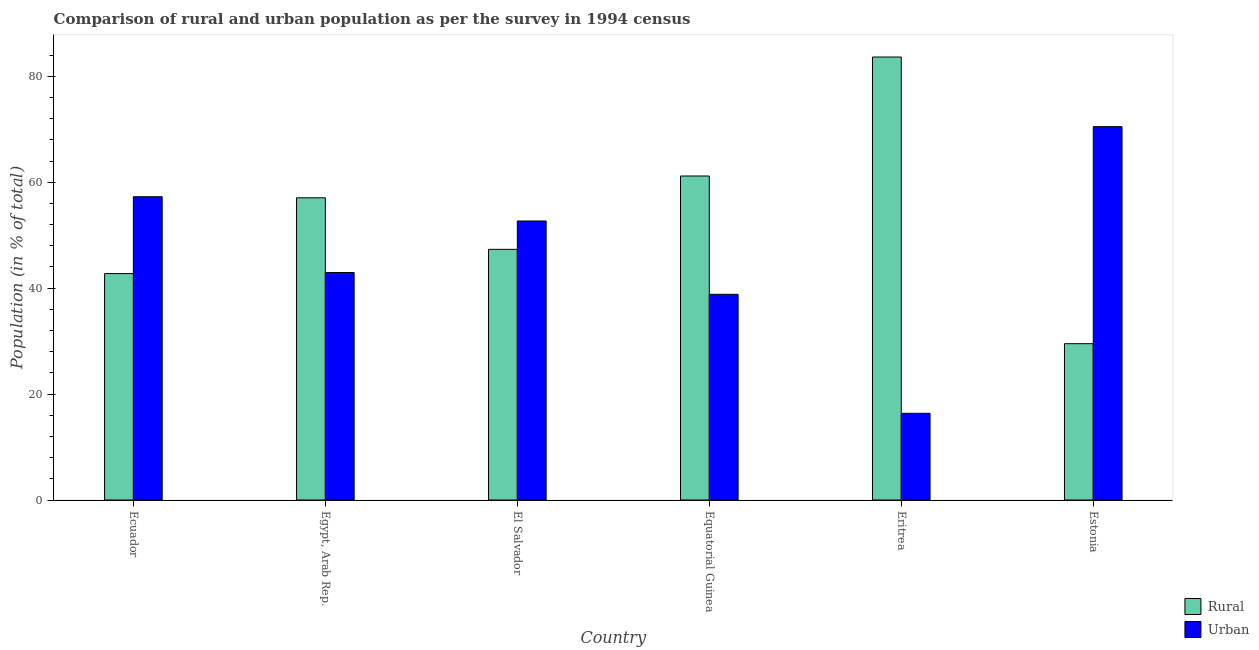How many different coloured bars are there?
Offer a terse response. 2. How many groups of bars are there?
Your answer should be compact. 6. Are the number of bars per tick equal to the number of legend labels?
Offer a terse response. Yes. How many bars are there on the 6th tick from the right?
Your answer should be compact. 2. What is the label of the 4th group of bars from the left?
Ensure brevity in your answer.  Equatorial Guinea. In how many cases, is the number of bars for a given country not equal to the number of legend labels?
Offer a very short reply. 0. What is the rural population in Egypt, Arab Rep.?
Offer a terse response. 57.05. Across all countries, what is the maximum rural population?
Give a very brief answer. 83.63. Across all countries, what is the minimum urban population?
Provide a short and direct response. 16.37. In which country was the rural population maximum?
Keep it short and to the point. Eritrea. In which country was the rural population minimum?
Ensure brevity in your answer.  Estonia. What is the total rural population in the graph?
Your response must be concise. 321.44. What is the difference between the urban population in Ecuador and that in El Salvador?
Your answer should be very brief. 4.58. What is the difference between the rural population in Estonia and the urban population in Equatorial Guinea?
Provide a succinct answer. -9.32. What is the average rural population per country?
Ensure brevity in your answer.  53.57. What is the difference between the rural population and urban population in El Salvador?
Make the answer very short. -5.35. What is the ratio of the rural population in Ecuador to that in Equatorial Guinea?
Provide a short and direct response. 0.7. Is the difference between the urban population in El Salvador and Eritrea greater than the difference between the rural population in El Salvador and Eritrea?
Provide a succinct answer. Yes. What is the difference between the highest and the second highest urban population?
Your answer should be compact. 13.23. What is the difference between the highest and the lowest rural population?
Your answer should be compact. 54.12. Is the sum of the urban population in Ecuador and Egypt, Arab Rep. greater than the maximum rural population across all countries?
Offer a terse response. Yes. What does the 2nd bar from the left in Ecuador represents?
Your answer should be very brief. Urban. What does the 1st bar from the right in El Salvador represents?
Your answer should be compact. Urban. How many bars are there?
Give a very brief answer. 12. Are all the bars in the graph horizontal?
Offer a very short reply. No. Does the graph contain grids?
Provide a succinct answer. No. How many legend labels are there?
Keep it short and to the point. 2. How are the legend labels stacked?
Keep it short and to the point. Vertical. What is the title of the graph?
Your answer should be very brief. Comparison of rural and urban population as per the survey in 1994 census. Does "Female population" appear as one of the legend labels in the graph?
Ensure brevity in your answer.  No. What is the label or title of the Y-axis?
Give a very brief answer. Population (in % of total). What is the Population (in % of total) in Rural in Ecuador?
Offer a terse response. 42.75. What is the Population (in % of total) in Urban in Ecuador?
Provide a short and direct response. 57.25. What is the Population (in % of total) of Rural in Egypt, Arab Rep.?
Your response must be concise. 57.05. What is the Population (in % of total) in Urban in Egypt, Arab Rep.?
Make the answer very short. 42.95. What is the Population (in % of total) of Rural in El Salvador?
Ensure brevity in your answer.  47.32. What is the Population (in % of total) in Urban in El Salvador?
Provide a succinct answer. 52.68. What is the Population (in % of total) of Rural in Equatorial Guinea?
Provide a succinct answer. 61.17. What is the Population (in % of total) of Urban in Equatorial Guinea?
Provide a succinct answer. 38.83. What is the Population (in % of total) of Rural in Eritrea?
Your answer should be compact. 83.63. What is the Population (in % of total) in Urban in Eritrea?
Provide a succinct answer. 16.37. What is the Population (in % of total) in Rural in Estonia?
Your answer should be compact. 29.51. What is the Population (in % of total) in Urban in Estonia?
Give a very brief answer. 70.49. Across all countries, what is the maximum Population (in % of total) of Rural?
Offer a very short reply. 83.63. Across all countries, what is the maximum Population (in % of total) of Urban?
Ensure brevity in your answer.  70.49. Across all countries, what is the minimum Population (in % of total) in Rural?
Make the answer very short. 29.51. Across all countries, what is the minimum Population (in % of total) in Urban?
Your answer should be compact. 16.37. What is the total Population (in % of total) of Rural in the graph?
Your answer should be compact. 321.44. What is the total Population (in % of total) of Urban in the graph?
Provide a succinct answer. 278.56. What is the difference between the Population (in % of total) in Rural in Ecuador and that in Egypt, Arab Rep.?
Provide a succinct answer. -14.31. What is the difference between the Population (in % of total) in Urban in Ecuador and that in Egypt, Arab Rep.?
Make the answer very short. 14.31. What is the difference between the Population (in % of total) in Rural in Ecuador and that in El Salvador?
Your answer should be compact. -4.58. What is the difference between the Population (in % of total) of Urban in Ecuador and that in El Salvador?
Make the answer very short. 4.58. What is the difference between the Population (in % of total) in Rural in Ecuador and that in Equatorial Guinea?
Offer a terse response. -18.42. What is the difference between the Population (in % of total) of Urban in Ecuador and that in Equatorial Guinea?
Ensure brevity in your answer.  18.42. What is the difference between the Population (in % of total) in Rural in Ecuador and that in Eritrea?
Provide a short and direct response. -40.89. What is the difference between the Population (in % of total) in Urban in Ecuador and that in Eritrea?
Your answer should be compact. 40.89. What is the difference between the Population (in % of total) in Rural in Ecuador and that in Estonia?
Make the answer very short. 13.23. What is the difference between the Population (in % of total) in Urban in Ecuador and that in Estonia?
Ensure brevity in your answer.  -13.23. What is the difference between the Population (in % of total) of Rural in Egypt, Arab Rep. and that in El Salvador?
Ensure brevity in your answer.  9.73. What is the difference between the Population (in % of total) in Urban in Egypt, Arab Rep. and that in El Salvador?
Your response must be concise. -9.73. What is the difference between the Population (in % of total) of Rural in Egypt, Arab Rep. and that in Equatorial Guinea?
Offer a very short reply. -4.12. What is the difference between the Population (in % of total) in Urban in Egypt, Arab Rep. and that in Equatorial Guinea?
Offer a very short reply. 4.12. What is the difference between the Population (in % of total) in Rural in Egypt, Arab Rep. and that in Eritrea?
Provide a short and direct response. -26.58. What is the difference between the Population (in % of total) of Urban in Egypt, Arab Rep. and that in Eritrea?
Make the answer very short. 26.58. What is the difference between the Population (in % of total) of Rural in Egypt, Arab Rep. and that in Estonia?
Your response must be concise. 27.54. What is the difference between the Population (in % of total) of Urban in Egypt, Arab Rep. and that in Estonia?
Your answer should be very brief. -27.54. What is the difference between the Population (in % of total) in Rural in El Salvador and that in Equatorial Guinea?
Provide a short and direct response. -13.85. What is the difference between the Population (in % of total) in Urban in El Salvador and that in Equatorial Guinea?
Give a very brief answer. 13.85. What is the difference between the Population (in % of total) of Rural in El Salvador and that in Eritrea?
Keep it short and to the point. -36.31. What is the difference between the Population (in % of total) in Urban in El Salvador and that in Eritrea?
Offer a very short reply. 36.31. What is the difference between the Population (in % of total) in Rural in El Salvador and that in Estonia?
Your answer should be very brief. 17.81. What is the difference between the Population (in % of total) in Urban in El Salvador and that in Estonia?
Your answer should be very brief. -17.81. What is the difference between the Population (in % of total) of Rural in Equatorial Guinea and that in Eritrea?
Make the answer very short. -22.46. What is the difference between the Population (in % of total) of Urban in Equatorial Guinea and that in Eritrea?
Give a very brief answer. 22.46. What is the difference between the Population (in % of total) in Rural in Equatorial Guinea and that in Estonia?
Ensure brevity in your answer.  31.66. What is the difference between the Population (in % of total) in Urban in Equatorial Guinea and that in Estonia?
Make the answer very short. -31.66. What is the difference between the Population (in % of total) in Rural in Eritrea and that in Estonia?
Your answer should be very brief. 54.12. What is the difference between the Population (in % of total) of Urban in Eritrea and that in Estonia?
Give a very brief answer. -54.12. What is the difference between the Population (in % of total) in Rural in Ecuador and the Population (in % of total) in Urban in El Salvador?
Provide a short and direct response. -9.93. What is the difference between the Population (in % of total) in Rural in Ecuador and the Population (in % of total) in Urban in Equatorial Guinea?
Make the answer very short. 3.92. What is the difference between the Population (in % of total) of Rural in Ecuador and the Population (in % of total) of Urban in Eritrea?
Make the answer very short. 26.38. What is the difference between the Population (in % of total) in Rural in Ecuador and the Population (in % of total) in Urban in Estonia?
Offer a terse response. -27.74. What is the difference between the Population (in % of total) in Rural in Egypt, Arab Rep. and the Population (in % of total) in Urban in El Salvador?
Ensure brevity in your answer.  4.38. What is the difference between the Population (in % of total) of Rural in Egypt, Arab Rep. and the Population (in % of total) of Urban in Equatorial Guinea?
Offer a terse response. 18.22. What is the difference between the Population (in % of total) of Rural in Egypt, Arab Rep. and the Population (in % of total) of Urban in Eritrea?
Your answer should be very brief. 40.69. What is the difference between the Population (in % of total) in Rural in Egypt, Arab Rep. and the Population (in % of total) in Urban in Estonia?
Offer a terse response. -13.43. What is the difference between the Population (in % of total) of Rural in El Salvador and the Population (in % of total) of Urban in Equatorial Guinea?
Keep it short and to the point. 8.49. What is the difference between the Population (in % of total) of Rural in El Salvador and the Population (in % of total) of Urban in Eritrea?
Offer a very short reply. 30.96. What is the difference between the Population (in % of total) of Rural in El Salvador and the Population (in % of total) of Urban in Estonia?
Your answer should be compact. -23.16. What is the difference between the Population (in % of total) of Rural in Equatorial Guinea and the Population (in % of total) of Urban in Eritrea?
Make the answer very short. 44.8. What is the difference between the Population (in % of total) in Rural in Equatorial Guinea and the Population (in % of total) in Urban in Estonia?
Provide a short and direct response. -9.32. What is the difference between the Population (in % of total) in Rural in Eritrea and the Population (in % of total) in Urban in Estonia?
Offer a terse response. 13.15. What is the average Population (in % of total) in Rural per country?
Your response must be concise. 53.57. What is the average Population (in % of total) in Urban per country?
Keep it short and to the point. 46.43. What is the difference between the Population (in % of total) in Rural and Population (in % of total) in Urban in Ecuador?
Your response must be concise. -14.51. What is the difference between the Population (in % of total) in Rural and Population (in % of total) in Urban in Egypt, Arab Rep.?
Give a very brief answer. 14.11. What is the difference between the Population (in % of total) in Rural and Population (in % of total) in Urban in El Salvador?
Your response must be concise. -5.35. What is the difference between the Population (in % of total) of Rural and Population (in % of total) of Urban in Equatorial Guinea?
Keep it short and to the point. 22.34. What is the difference between the Population (in % of total) in Rural and Population (in % of total) in Urban in Eritrea?
Make the answer very short. 67.27. What is the difference between the Population (in % of total) of Rural and Population (in % of total) of Urban in Estonia?
Provide a short and direct response. -40.97. What is the ratio of the Population (in % of total) in Rural in Ecuador to that in Egypt, Arab Rep.?
Provide a short and direct response. 0.75. What is the ratio of the Population (in % of total) of Urban in Ecuador to that in Egypt, Arab Rep.?
Ensure brevity in your answer.  1.33. What is the ratio of the Population (in % of total) of Rural in Ecuador to that in El Salvador?
Ensure brevity in your answer.  0.9. What is the ratio of the Population (in % of total) of Urban in Ecuador to that in El Salvador?
Your answer should be very brief. 1.09. What is the ratio of the Population (in % of total) in Rural in Ecuador to that in Equatorial Guinea?
Your answer should be compact. 0.7. What is the ratio of the Population (in % of total) in Urban in Ecuador to that in Equatorial Guinea?
Make the answer very short. 1.47. What is the ratio of the Population (in % of total) in Rural in Ecuador to that in Eritrea?
Your response must be concise. 0.51. What is the ratio of the Population (in % of total) in Urban in Ecuador to that in Eritrea?
Keep it short and to the point. 3.5. What is the ratio of the Population (in % of total) of Rural in Ecuador to that in Estonia?
Your answer should be very brief. 1.45. What is the ratio of the Population (in % of total) in Urban in Ecuador to that in Estonia?
Keep it short and to the point. 0.81. What is the ratio of the Population (in % of total) in Rural in Egypt, Arab Rep. to that in El Salvador?
Your answer should be very brief. 1.21. What is the ratio of the Population (in % of total) in Urban in Egypt, Arab Rep. to that in El Salvador?
Offer a very short reply. 0.82. What is the ratio of the Population (in % of total) in Rural in Egypt, Arab Rep. to that in Equatorial Guinea?
Make the answer very short. 0.93. What is the ratio of the Population (in % of total) of Urban in Egypt, Arab Rep. to that in Equatorial Guinea?
Make the answer very short. 1.11. What is the ratio of the Population (in % of total) in Rural in Egypt, Arab Rep. to that in Eritrea?
Make the answer very short. 0.68. What is the ratio of the Population (in % of total) of Urban in Egypt, Arab Rep. to that in Eritrea?
Provide a short and direct response. 2.62. What is the ratio of the Population (in % of total) in Rural in Egypt, Arab Rep. to that in Estonia?
Provide a succinct answer. 1.93. What is the ratio of the Population (in % of total) of Urban in Egypt, Arab Rep. to that in Estonia?
Provide a succinct answer. 0.61. What is the ratio of the Population (in % of total) in Rural in El Salvador to that in Equatorial Guinea?
Offer a very short reply. 0.77. What is the ratio of the Population (in % of total) of Urban in El Salvador to that in Equatorial Guinea?
Offer a very short reply. 1.36. What is the ratio of the Population (in % of total) in Rural in El Salvador to that in Eritrea?
Ensure brevity in your answer.  0.57. What is the ratio of the Population (in % of total) of Urban in El Salvador to that in Eritrea?
Your answer should be very brief. 3.22. What is the ratio of the Population (in % of total) of Rural in El Salvador to that in Estonia?
Offer a very short reply. 1.6. What is the ratio of the Population (in % of total) in Urban in El Salvador to that in Estonia?
Provide a succinct answer. 0.75. What is the ratio of the Population (in % of total) of Rural in Equatorial Guinea to that in Eritrea?
Make the answer very short. 0.73. What is the ratio of the Population (in % of total) in Urban in Equatorial Guinea to that in Eritrea?
Your answer should be compact. 2.37. What is the ratio of the Population (in % of total) of Rural in Equatorial Guinea to that in Estonia?
Your answer should be very brief. 2.07. What is the ratio of the Population (in % of total) in Urban in Equatorial Guinea to that in Estonia?
Ensure brevity in your answer.  0.55. What is the ratio of the Population (in % of total) in Rural in Eritrea to that in Estonia?
Provide a succinct answer. 2.83. What is the ratio of the Population (in % of total) in Urban in Eritrea to that in Estonia?
Provide a short and direct response. 0.23. What is the difference between the highest and the second highest Population (in % of total) of Rural?
Provide a succinct answer. 22.46. What is the difference between the highest and the second highest Population (in % of total) of Urban?
Keep it short and to the point. 13.23. What is the difference between the highest and the lowest Population (in % of total) in Rural?
Offer a terse response. 54.12. What is the difference between the highest and the lowest Population (in % of total) of Urban?
Your answer should be very brief. 54.12. 